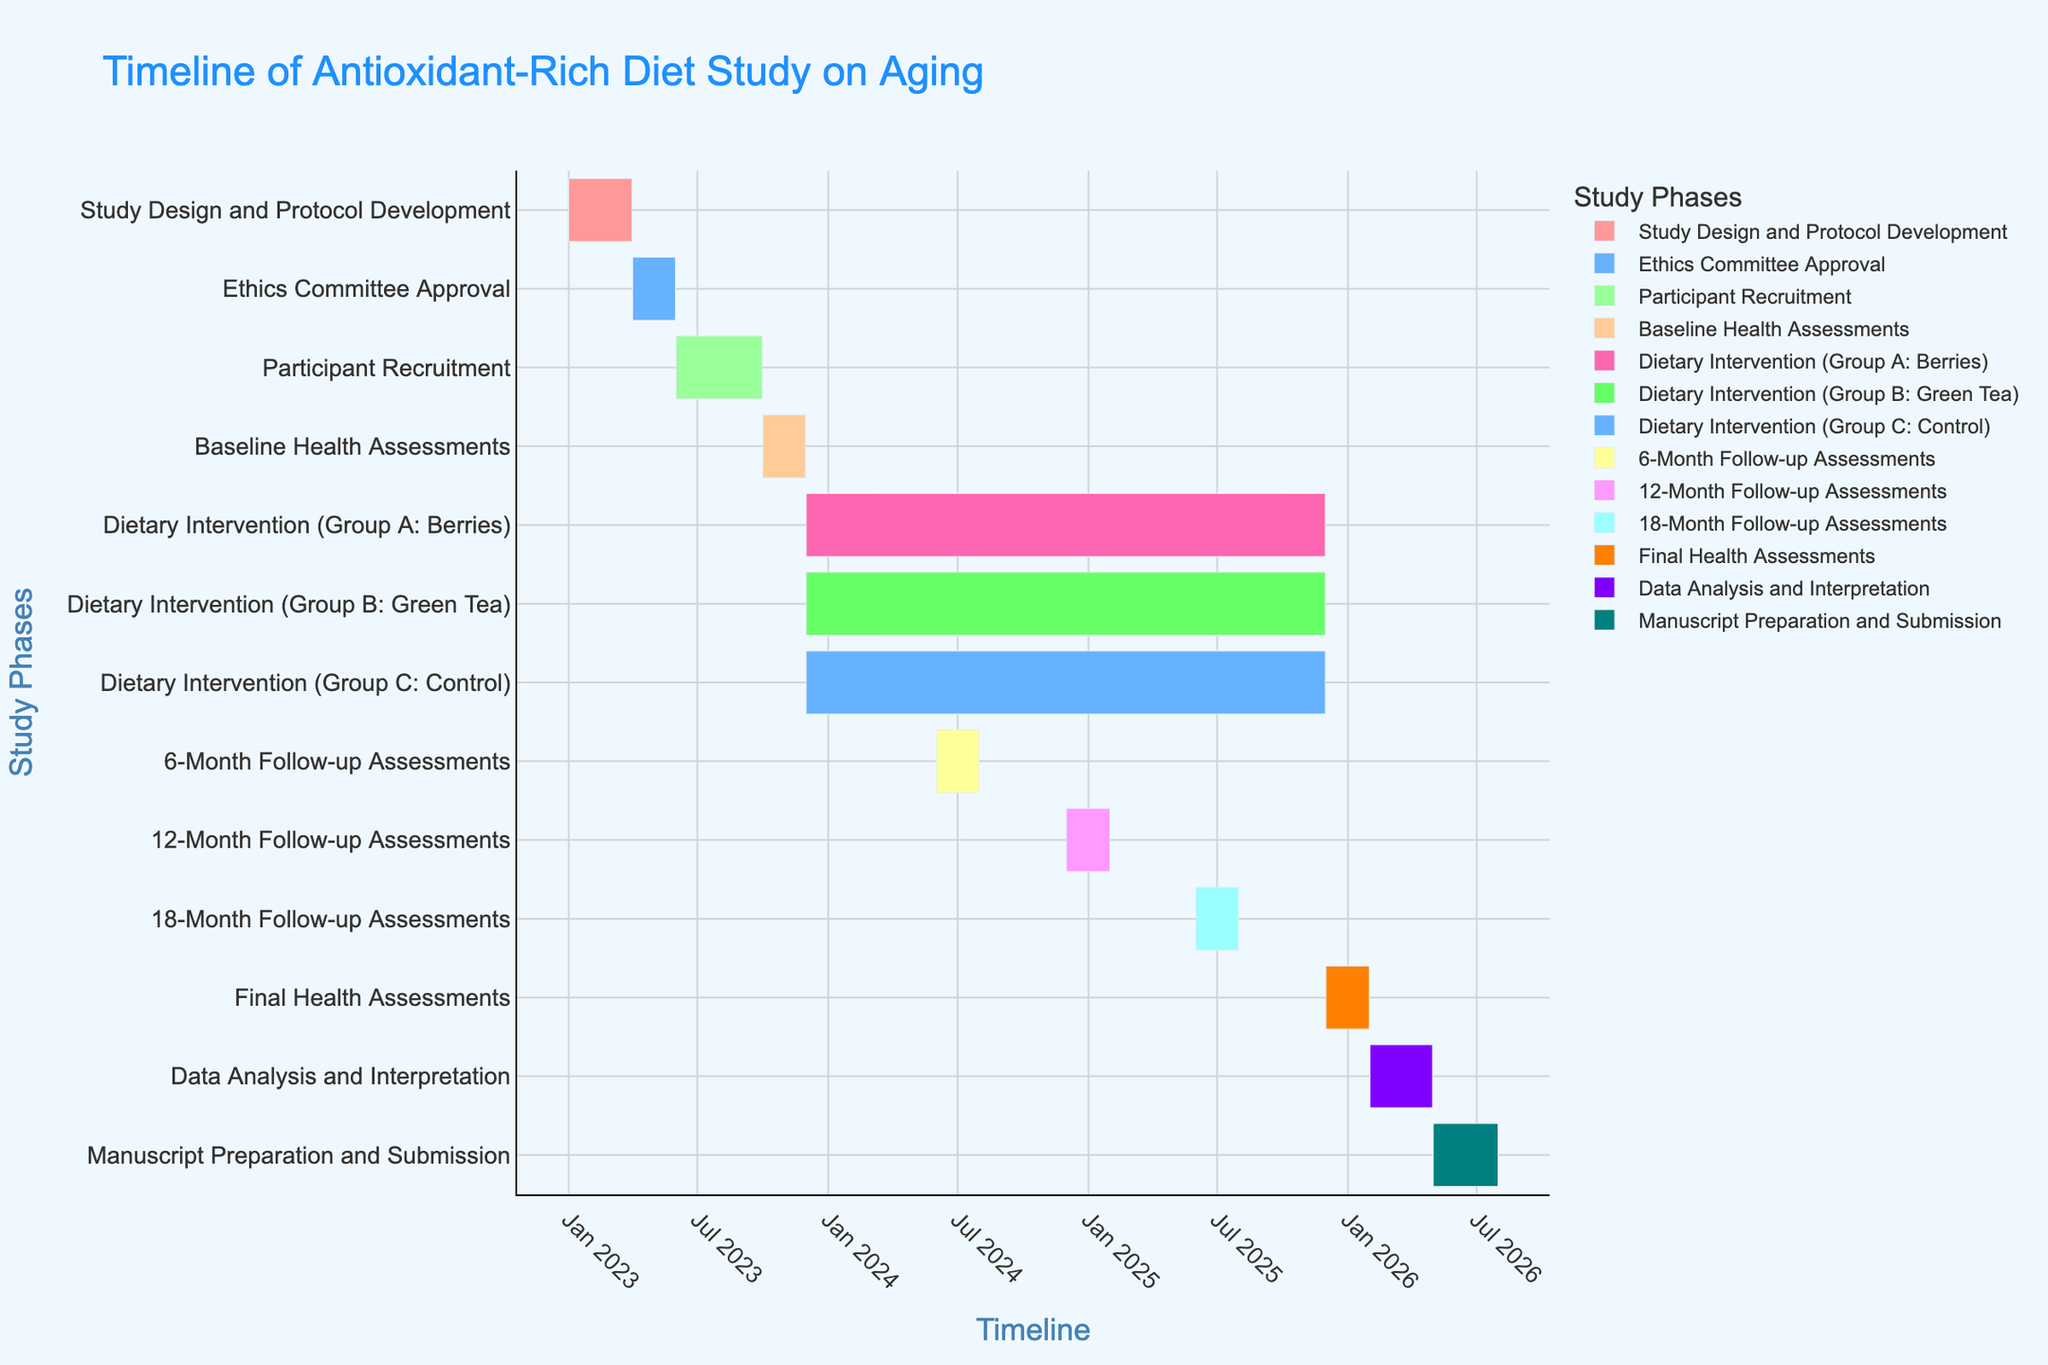What is the total duration of the 'Participant Recruitment' phase? The 'Participant Recruitment' phase starts on 2023-06-01 and ends on 2023-09-30. The total duration can be calculated by subtracting the start date from the end date. This results in a duration of 121 days.
Answer: 121 days What is the title of the Gantt chart? The title is displayed at the top of the Gantt chart and reads "Timeline of Antioxidant-Rich Diet Study on Aging."
Answer: Timeline of Antioxidant-Rich Diet Study on Aging Which phases occur in December 2023? According to the visual timeline, the phases occurring in December 2023 are 'Dietary Intervention (Group A: Berries)', 'Dietary Intervention (Group B: Green Tea)', and 'Dietary Intervention (Group C: Control)'.
Answer: Dietary Intervention (Group A: Berries), Dietary Intervention (Group B: Green Tea), Dietary Intervention (Group C: Control) How many phases are involved in the dietary intervention and for how long do they last? The dietary intervention involves three phases: 'Dietary Intervention (Group A: Berries)', 'Dietary Intervention (Group B: Green Tea)', and 'Dietary Intervention (Group C: Control)'. Each phase starts on 2023-12-01 and ends on 2025-11-30, resulting in a duration of two years.
Answer: 3 phases, 2 years Which phase follows the '18-Month Follow-up Assessments'? Utilizing the sequence of tasks in the Gantt chart, the phase following the '18-Month Follow-up Assessments' (which ends on 2025-07-31) is 'Final Health Assessments' starting on 2025-12-01.
Answer: Final Health Assessments What is the difference in duration between the 'Study Design and Protocol Development' phase and the 'Data Analysis and Interpretation' phase? The 'Study Design and Protocol Development' phase lasts from 2023-01-01 to 2023-03-31 (90 days), while the 'Data Analysis and Interpretation' phase lasts from 2026-02-01 to 2026-04-30 (89 days). The difference in duration can be calculated as 90 - 89 = 1 day.
Answer: 1 day Do 'Baseline Health Assessments' and 'Manuscript Preparation and Submission' overlap? 'Baseline Health Assessments' span from 2023-10-01 to 2023-11-30, and 'Manuscript Preparation and Submission' span from 2026-05-01 to 2026-07-31. Checking the timeline, there is no overlap between these two phases.
Answer: No Which phase is the longest and how long does it last? From the visual information in the Gantt chart, the longest phases are the dietary interventions ('Dietary Intervention (Group A: Berries)', 'Dietary Intervention (Group B: Green Tea)', and 'Dietary Intervention (Group C: Control)'), each lasting from 2023-12-01 to 2025-11-30, totaling 730 days.
Answer: Dietary Interventions, 730 days How many months does the 'Manuscript Preparation and Submission' phase take? 'Manuscript Preparation and Submission' starts on 2026-05-01 and ends on 2026-07-31. This spans a period of 3 months (May, June, and July).
Answer: 3 months 